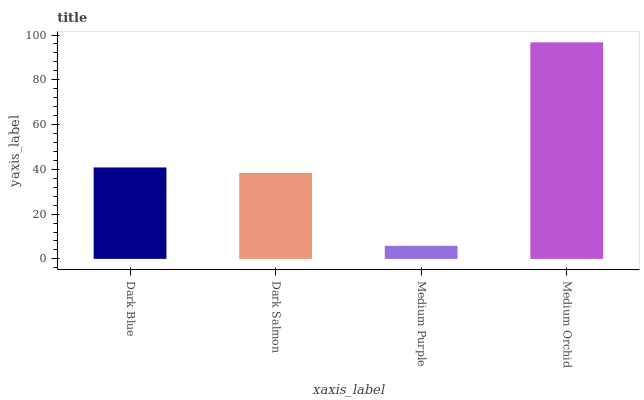Is Medium Purple the minimum?
Answer yes or no. Yes. Is Medium Orchid the maximum?
Answer yes or no. Yes. Is Dark Salmon the minimum?
Answer yes or no. No. Is Dark Salmon the maximum?
Answer yes or no. No. Is Dark Blue greater than Dark Salmon?
Answer yes or no. Yes. Is Dark Salmon less than Dark Blue?
Answer yes or no. Yes. Is Dark Salmon greater than Dark Blue?
Answer yes or no. No. Is Dark Blue less than Dark Salmon?
Answer yes or no. No. Is Dark Blue the high median?
Answer yes or no. Yes. Is Dark Salmon the low median?
Answer yes or no. Yes. Is Dark Salmon the high median?
Answer yes or no. No. Is Medium Purple the low median?
Answer yes or no. No. 